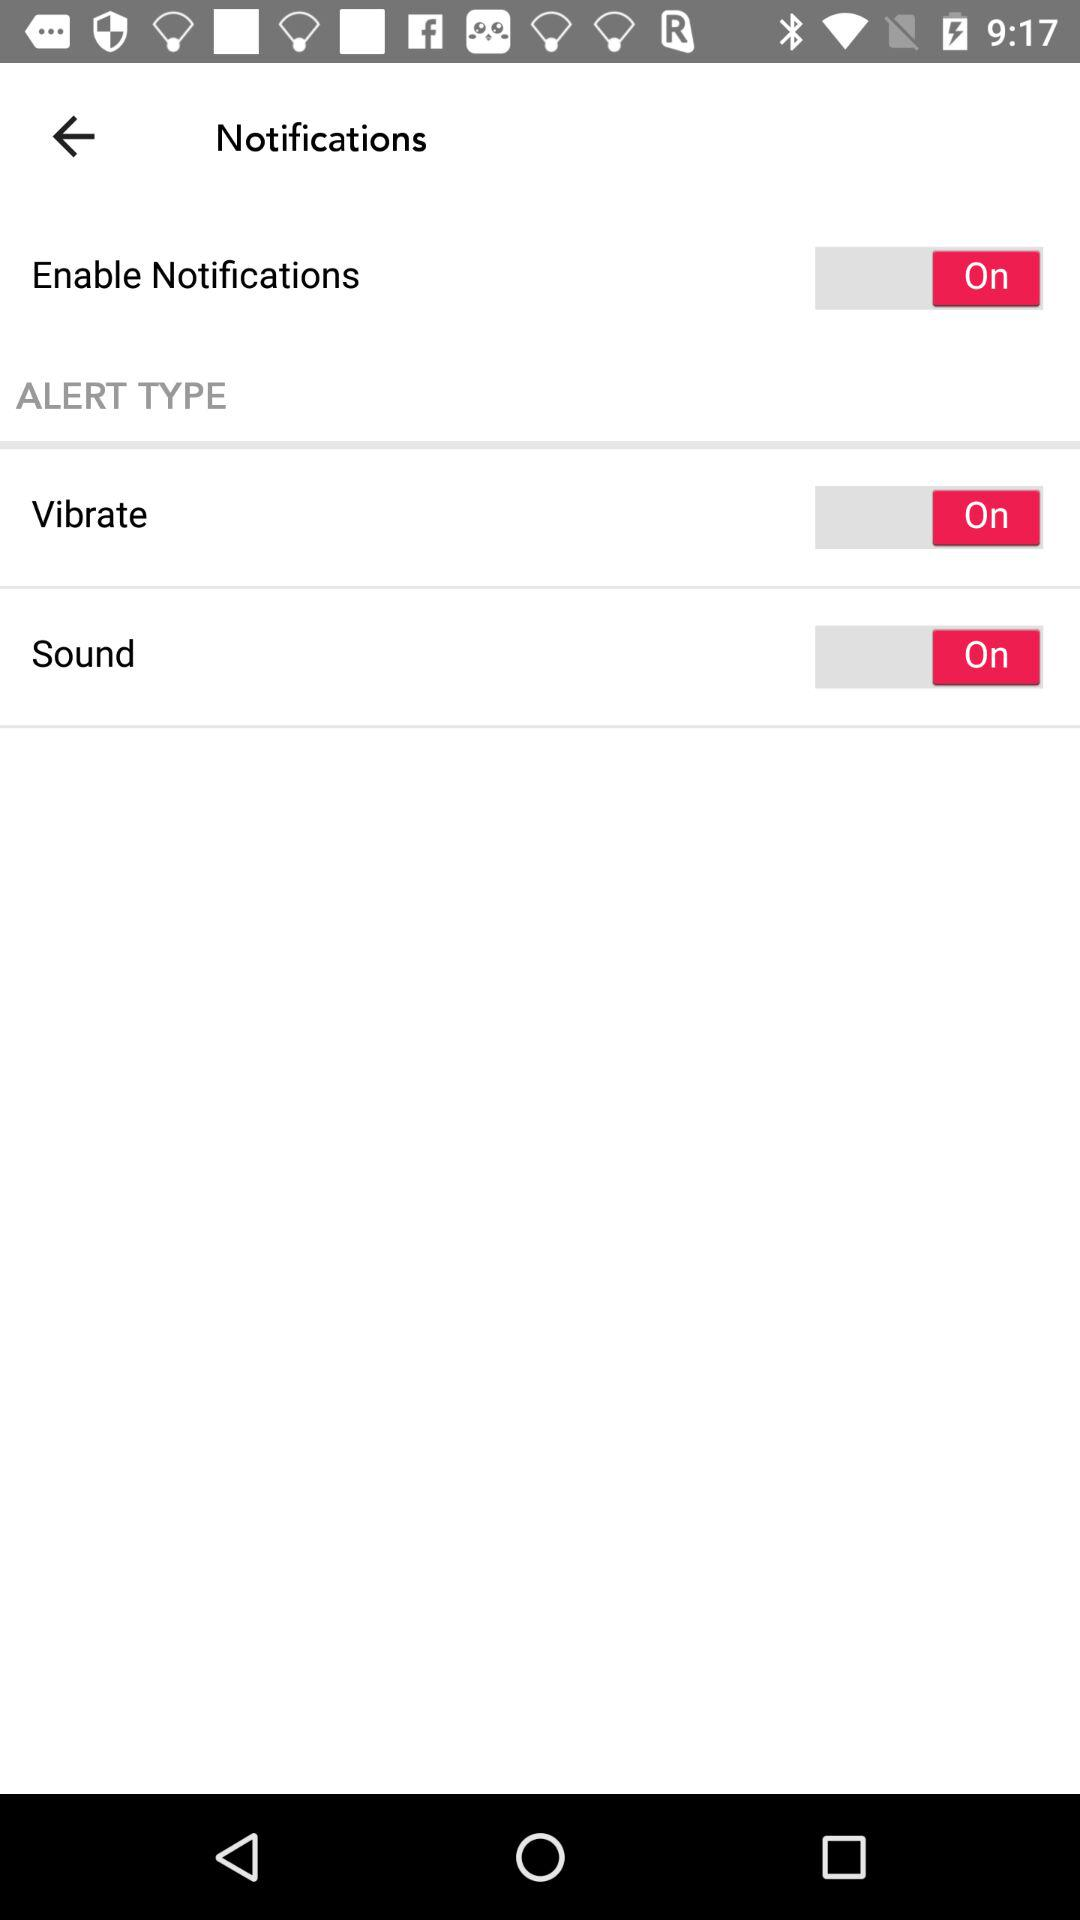How many switch controls are there?
Answer the question using a single word or phrase. 3 